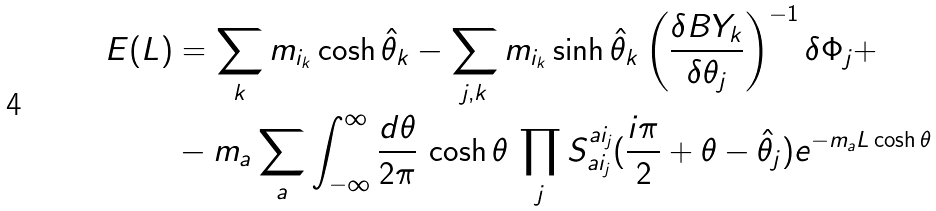<formula> <loc_0><loc_0><loc_500><loc_500>E ( L ) & = \sum _ { k } m _ { i _ { k } } \cosh \hat { \theta } _ { k } - \sum _ { j , k } m _ { i _ { k } } \sinh \hat { \theta } _ { k } \left ( \frac { \delta B Y _ { k } } { \delta \theta _ { j } } \right ) ^ { - 1 } \delta \Phi _ { j } + \\ & - m _ { a } \sum _ { a } \int _ { - \infty } ^ { \infty } \frac { d \theta } { 2 \pi } \, \cosh \theta \, \prod _ { j } S _ { a i _ { j } } ^ { a i _ { j } } ( \frac { i \pi } { 2 } + \theta - \hat { \theta } _ { j } ) e ^ { - m _ { a } L \cosh \theta }</formula> 